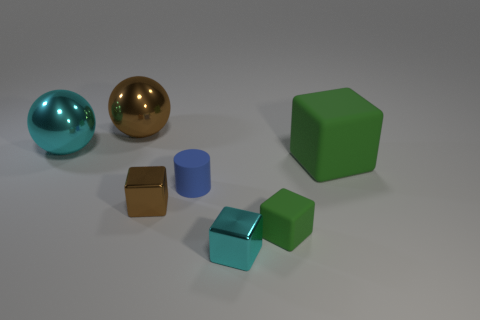Do the blue object and the brown thing that is in front of the large green rubber block have the same shape?
Offer a very short reply. No. Is the number of tiny brown shiny cubes that are behind the big cyan object less than the number of big matte cubes that are to the right of the small cyan metal cube?
Your answer should be very brief. Yes. Is there any other thing that has the same shape as the blue object?
Keep it short and to the point. No. Does the tiny brown object have the same shape as the large rubber thing?
Make the answer very short. Yes. The brown block has what size?
Offer a terse response. Small. What color is the object that is both behind the small brown cube and to the right of the tiny cyan thing?
Your answer should be very brief. Green. Is the number of tiny brown blocks greater than the number of brown rubber things?
Give a very brief answer. Yes. How many things are small brown metal objects or things to the left of the small cyan shiny thing?
Provide a succinct answer. 4. Is the size of the cyan metal block the same as the cyan sphere?
Ensure brevity in your answer.  No. There is a tiny green block; are there any things right of it?
Give a very brief answer. Yes. 